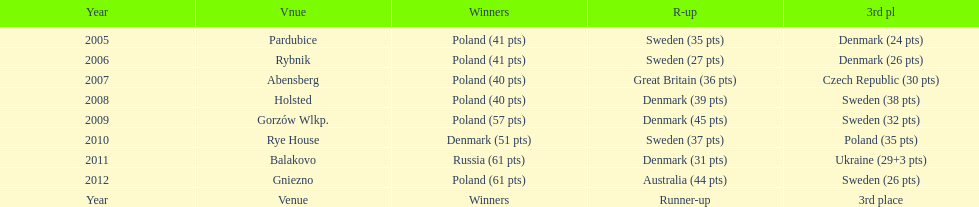From 2005-2012, in the team speedway junior world championship, how many more first place wins than all other teams put together? Poland. 